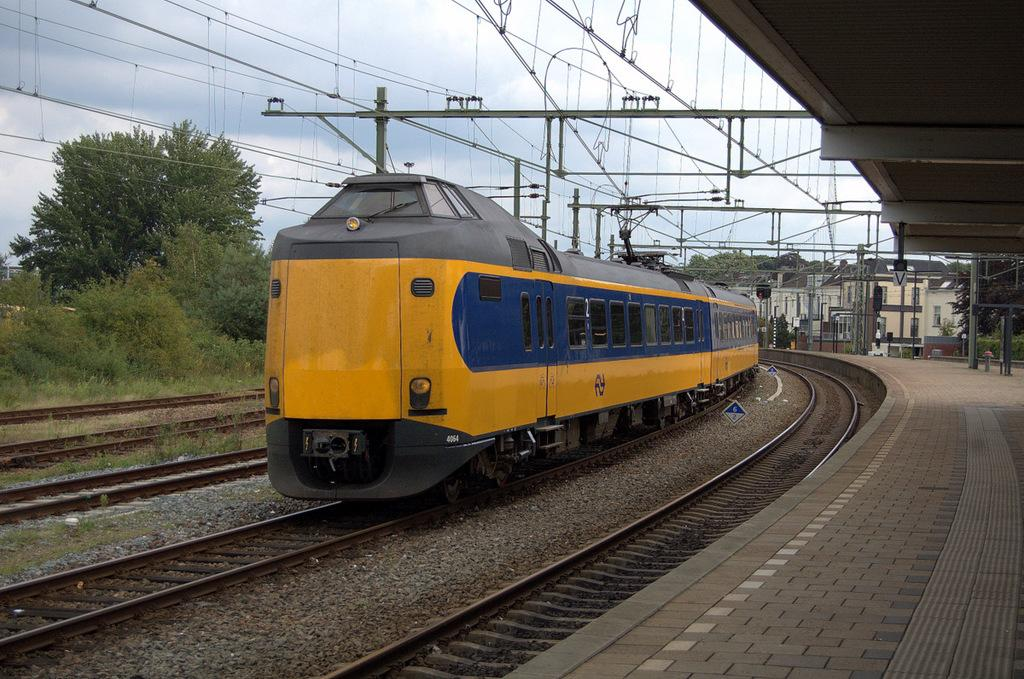What is the color of the train in the image? The train in the image is yellow. Where is the train located in the image? The train is on a track. What can be seen in the background of the image? There are trees in the background of the image. What is present above the train in the image? There are cables over the train. What type of trouble is the train causing in the room during the summer? There is no room or summer mentioned in the image, and the train is not causing any trouble. 